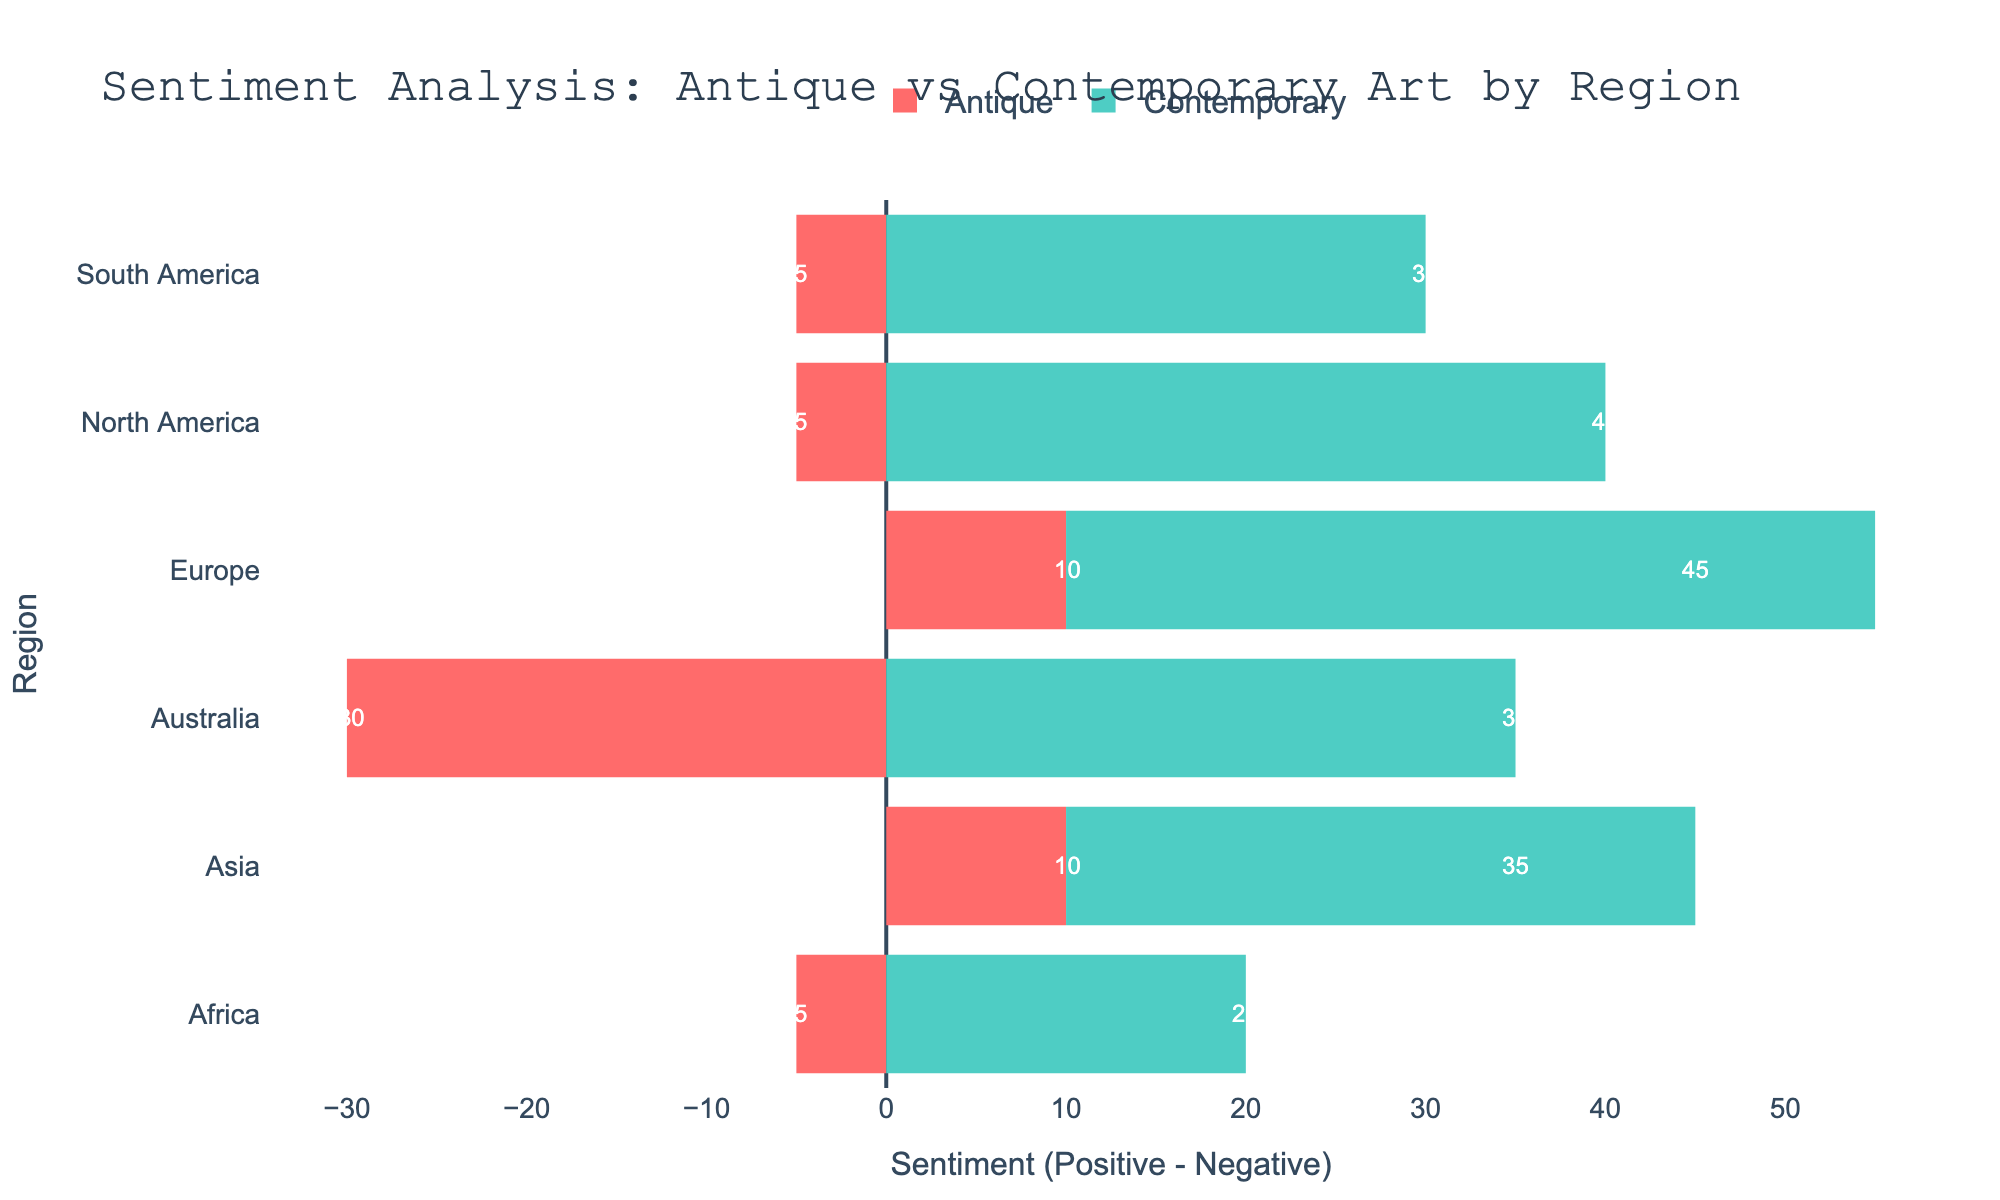Which region has the highest positive sentiment for contemporary art? The positive sentiment for contemporary art in each region: North America (55), Europe (60), Asia (50), South America (45), Africa (40), Australia (55). Europe has the highest value of 60.
Answer: Europe Which type of art in Asia has a lower neutral sentiment? The neutral sentiment for both types in Asia: Antique (30), Contemporary (35). Antique has a lower value of 30.
Answer: Antique What is the combined positive sentiment for antique art in North America and Europe? The positive sentiment for antique art in North America (35) and Europe (45) combined is 35 + 45 = 80.
Answer: 80 Which region has an equal neutral sentiment for both types of art? The neutral sentiment for both types in South America is 35.
Answer: South America How does the visual length of positive sentiment bars compare between North America and Europe for contemporary art? Visually, in North America and Europe for contemporary art, the positive sentiment bar in Europe (60) is longer than in North America (55).
Answer: Europe is longer Which region shows the most significant negative sentiment for contemporary art? The negative sentiment for contemporary art in each region: North America (15), Europe (15), Asia (15), South America (15), Africa (20), Australia (20). Australia and Africa both have the highest negative sentiment of 20.
Answer: Australia and Africa 